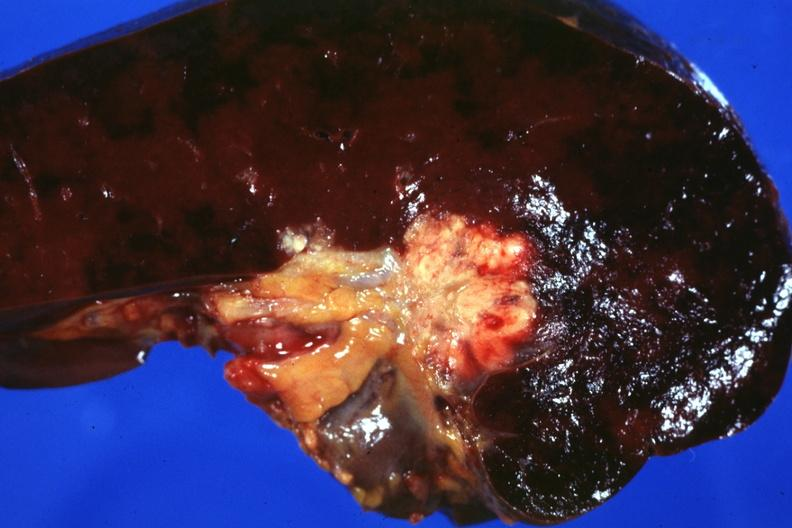s metastatic colon carcinoma present?
Answer the question using a single word or phrase. Yes 